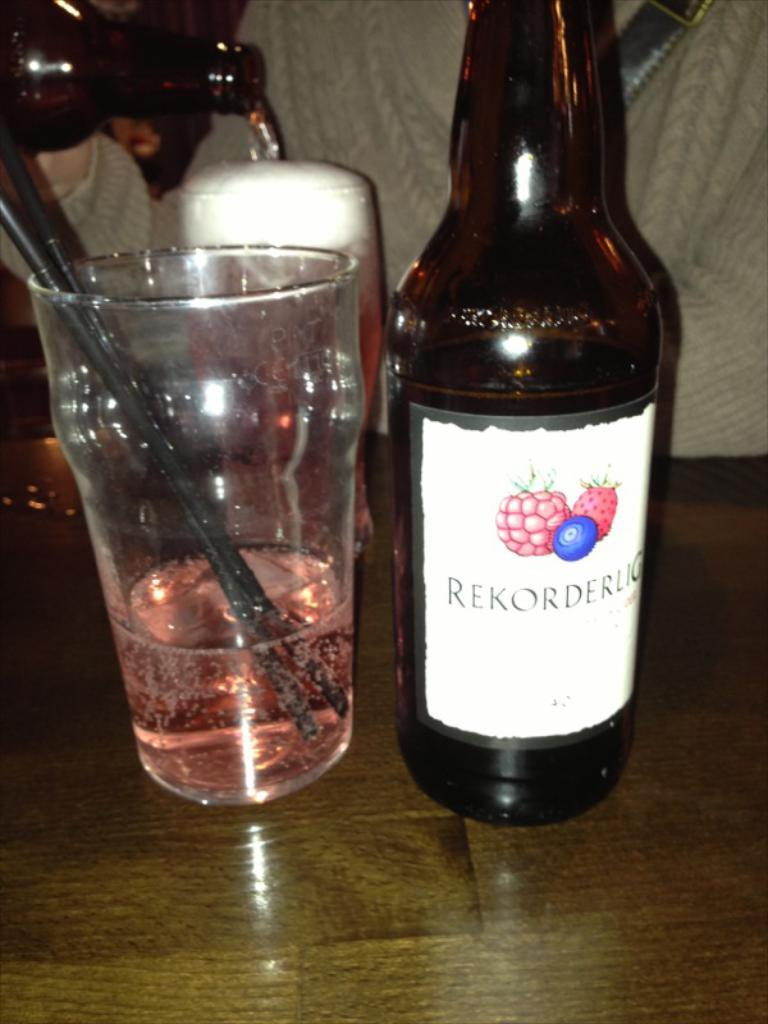<image>
Present a compact description of the photo's key features. A bottle of Rekorderug has been poured into a glass 